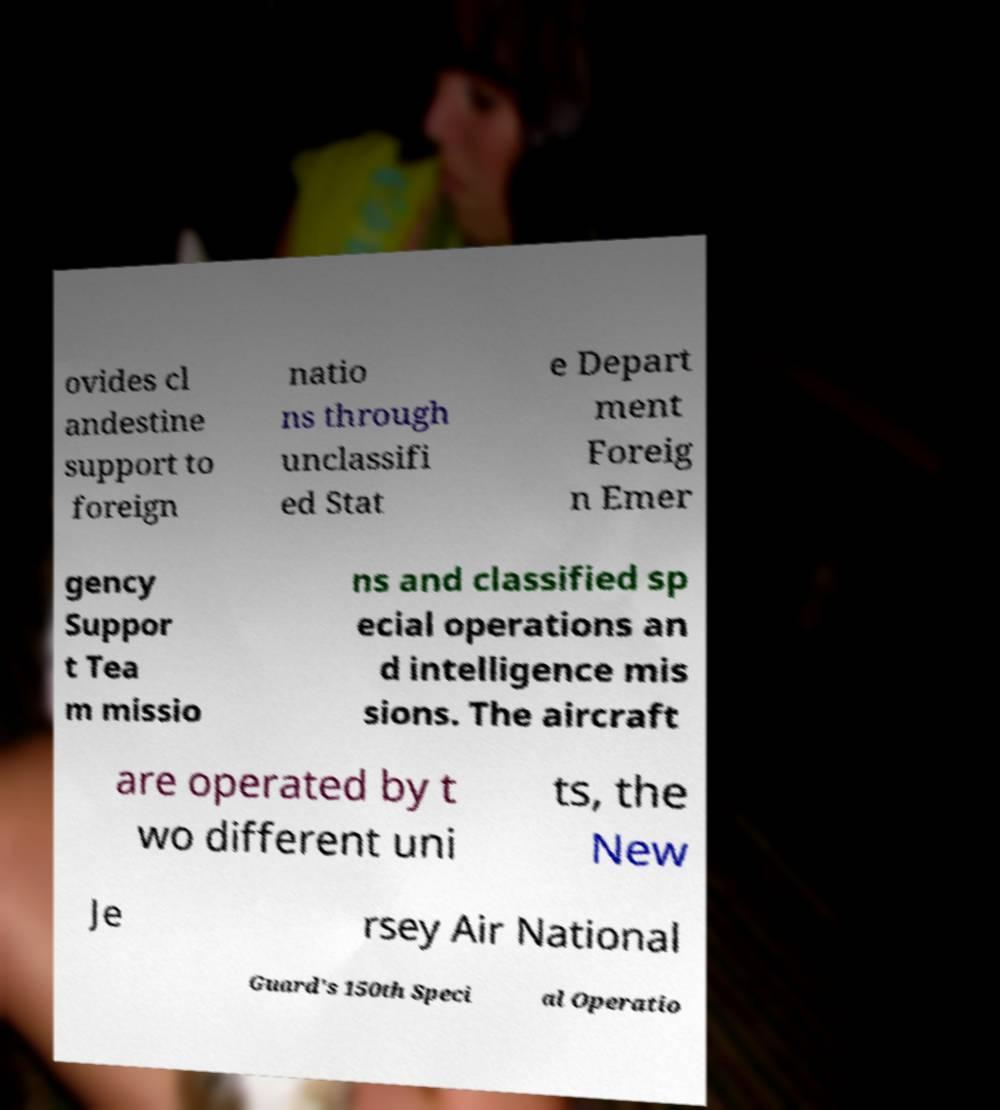What messages or text are displayed in this image? I need them in a readable, typed format. ovides cl andestine support to foreign natio ns through unclassifi ed Stat e Depart ment Foreig n Emer gency Suppor t Tea m missio ns and classified sp ecial operations an d intelligence mis sions. The aircraft are operated by t wo different uni ts, the New Je rsey Air National Guard's 150th Speci al Operatio 